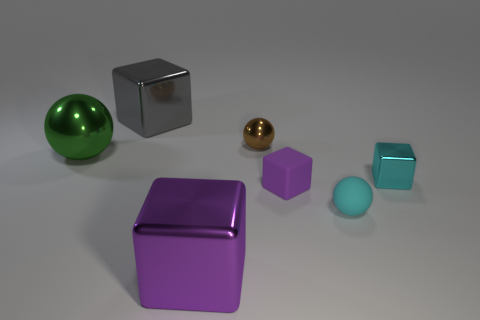Add 1 gray rubber spheres. How many objects exist? 8 Subtract all cubes. How many objects are left? 3 Subtract 0 gray spheres. How many objects are left? 7 Subtract all small cubes. Subtract all tiny balls. How many objects are left? 3 Add 4 large green objects. How many large green objects are left? 5 Add 1 large yellow rubber cubes. How many large yellow rubber cubes exist? 1 